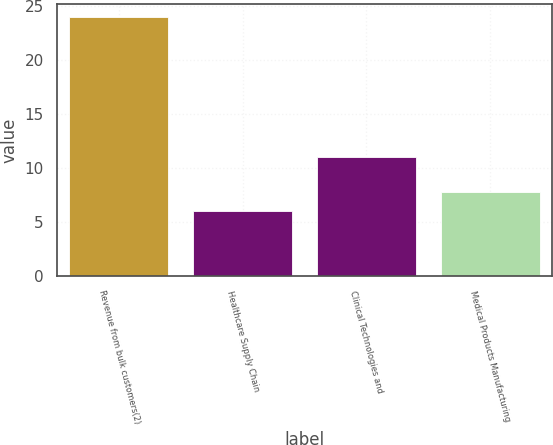Convert chart to OTSL. <chart><loc_0><loc_0><loc_500><loc_500><bar_chart><fcel>Revenue from bulk customers(2)<fcel>Healthcare Supply Chain<fcel>Clinical Technologies and<fcel>Medical Products Manufacturing<nl><fcel>24<fcel>6<fcel>11<fcel>7.8<nl></chart> 